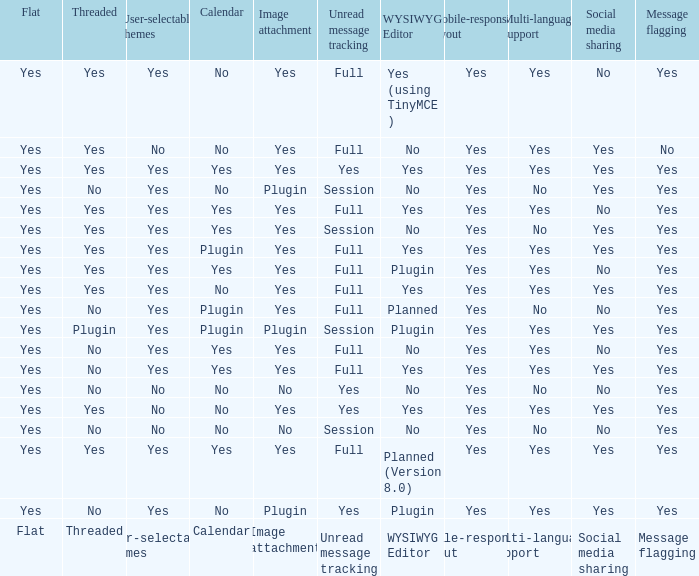Which Calendar has a WYSIWYG Editor of no, and an Unread message tracking of session, and an Image attachment of no? No. 